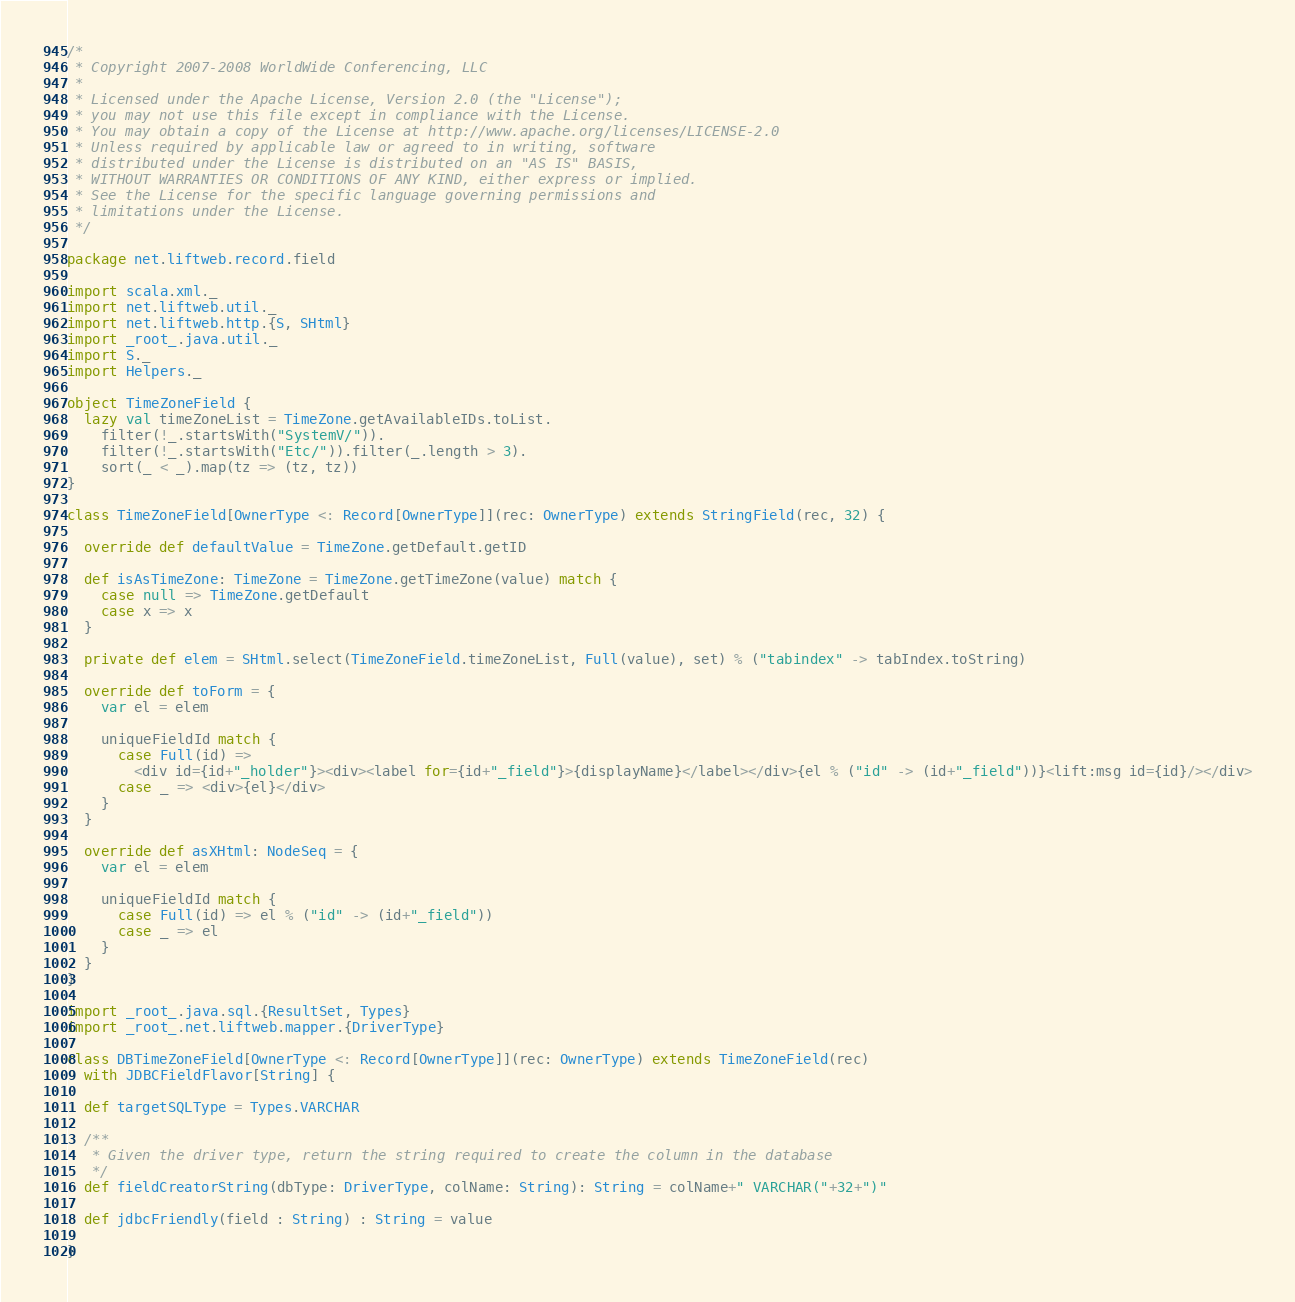Convert code to text. <code><loc_0><loc_0><loc_500><loc_500><_Scala_>/*
 * Copyright 2007-2008 WorldWide Conferencing, LLC
 *
 * Licensed under the Apache License, Version 2.0 (the "License");
 * you may not use this file except in compliance with the License.
 * You may obtain a copy of the License at http://www.apache.org/licenses/LICENSE-2.0
 * Unless required by applicable law or agreed to in writing, software
 * distributed under the License is distributed on an "AS IS" BASIS,
 * WITHOUT WARRANTIES OR CONDITIONS OF ANY KIND, either express or implied.
 * See the License for the specific language governing permissions and
 * limitations under the License.
 */

package net.liftweb.record.field

import scala.xml._
import net.liftweb.util._
import net.liftweb.http.{S, SHtml}
import _root_.java.util._
import S._
import Helpers._

object TimeZoneField {
  lazy val timeZoneList = TimeZone.getAvailableIDs.toList.
    filter(!_.startsWith("SystemV/")).
    filter(!_.startsWith("Etc/")).filter(_.length > 3).
    sort(_ < _).map(tz => (tz, tz))
}

class TimeZoneField[OwnerType <: Record[OwnerType]](rec: OwnerType) extends StringField(rec, 32) {

  override def defaultValue = TimeZone.getDefault.getID

  def isAsTimeZone: TimeZone = TimeZone.getTimeZone(value) match {
    case null => TimeZone.getDefault
    case x => x
  }

  private def elem = SHtml.select(TimeZoneField.timeZoneList, Full(value), set) % ("tabindex" -> tabIndex.toString)

  override def toForm = {
    var el = elem

    uniqueFieldId match {
      case Full(id) =>
        <div id={id+"_holder"}><div><label for={id+"_field"}>{displayName}</label></div>{el % ("id" -> (id+"_field"))}<lift:msg id={id}/></div>
      case _ => <div>{el}</div>
    }
  }

  override def asXHtml: NodeSeq = {
    var el = elem

    uniqueFieldId match {
      case Full(id) => el % ("id" -> (id+"_field"))
      case _ => el
    }
  }
}

import _root_.java.sql.{ResultSet, Types}
import _root_.net.liftweb.mapper.{DriverType}

class DBTimeZoneField[OwnerType <: Record[OwnerType]](rec: OwnerType) extends TimeZoneField(rec)
  with JDBCFieldFlavor[String] {

  def targetSQLType = Types.VARCHAR

  /**
   * Given the driver type, return the string required to create the column in the database
   */
  def fieldCreatorString(dbType: DriverType, colName: String): String = colName+" VARCHAR("+32+")"

  def jdbcFriendly(field : String) : String = value

}
</code> 